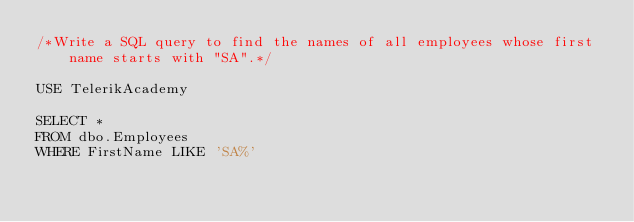<code> <loc_0><loc_0><loc_500><loc_500><_SQL_>/*Write a SQL query to find the names of all employees whose first name starts with "SA".*/

USE TelerikAcademy

SELECT *
FROM dbo.Employees
WHERE FirstName LIKE 'SA%'</code> 